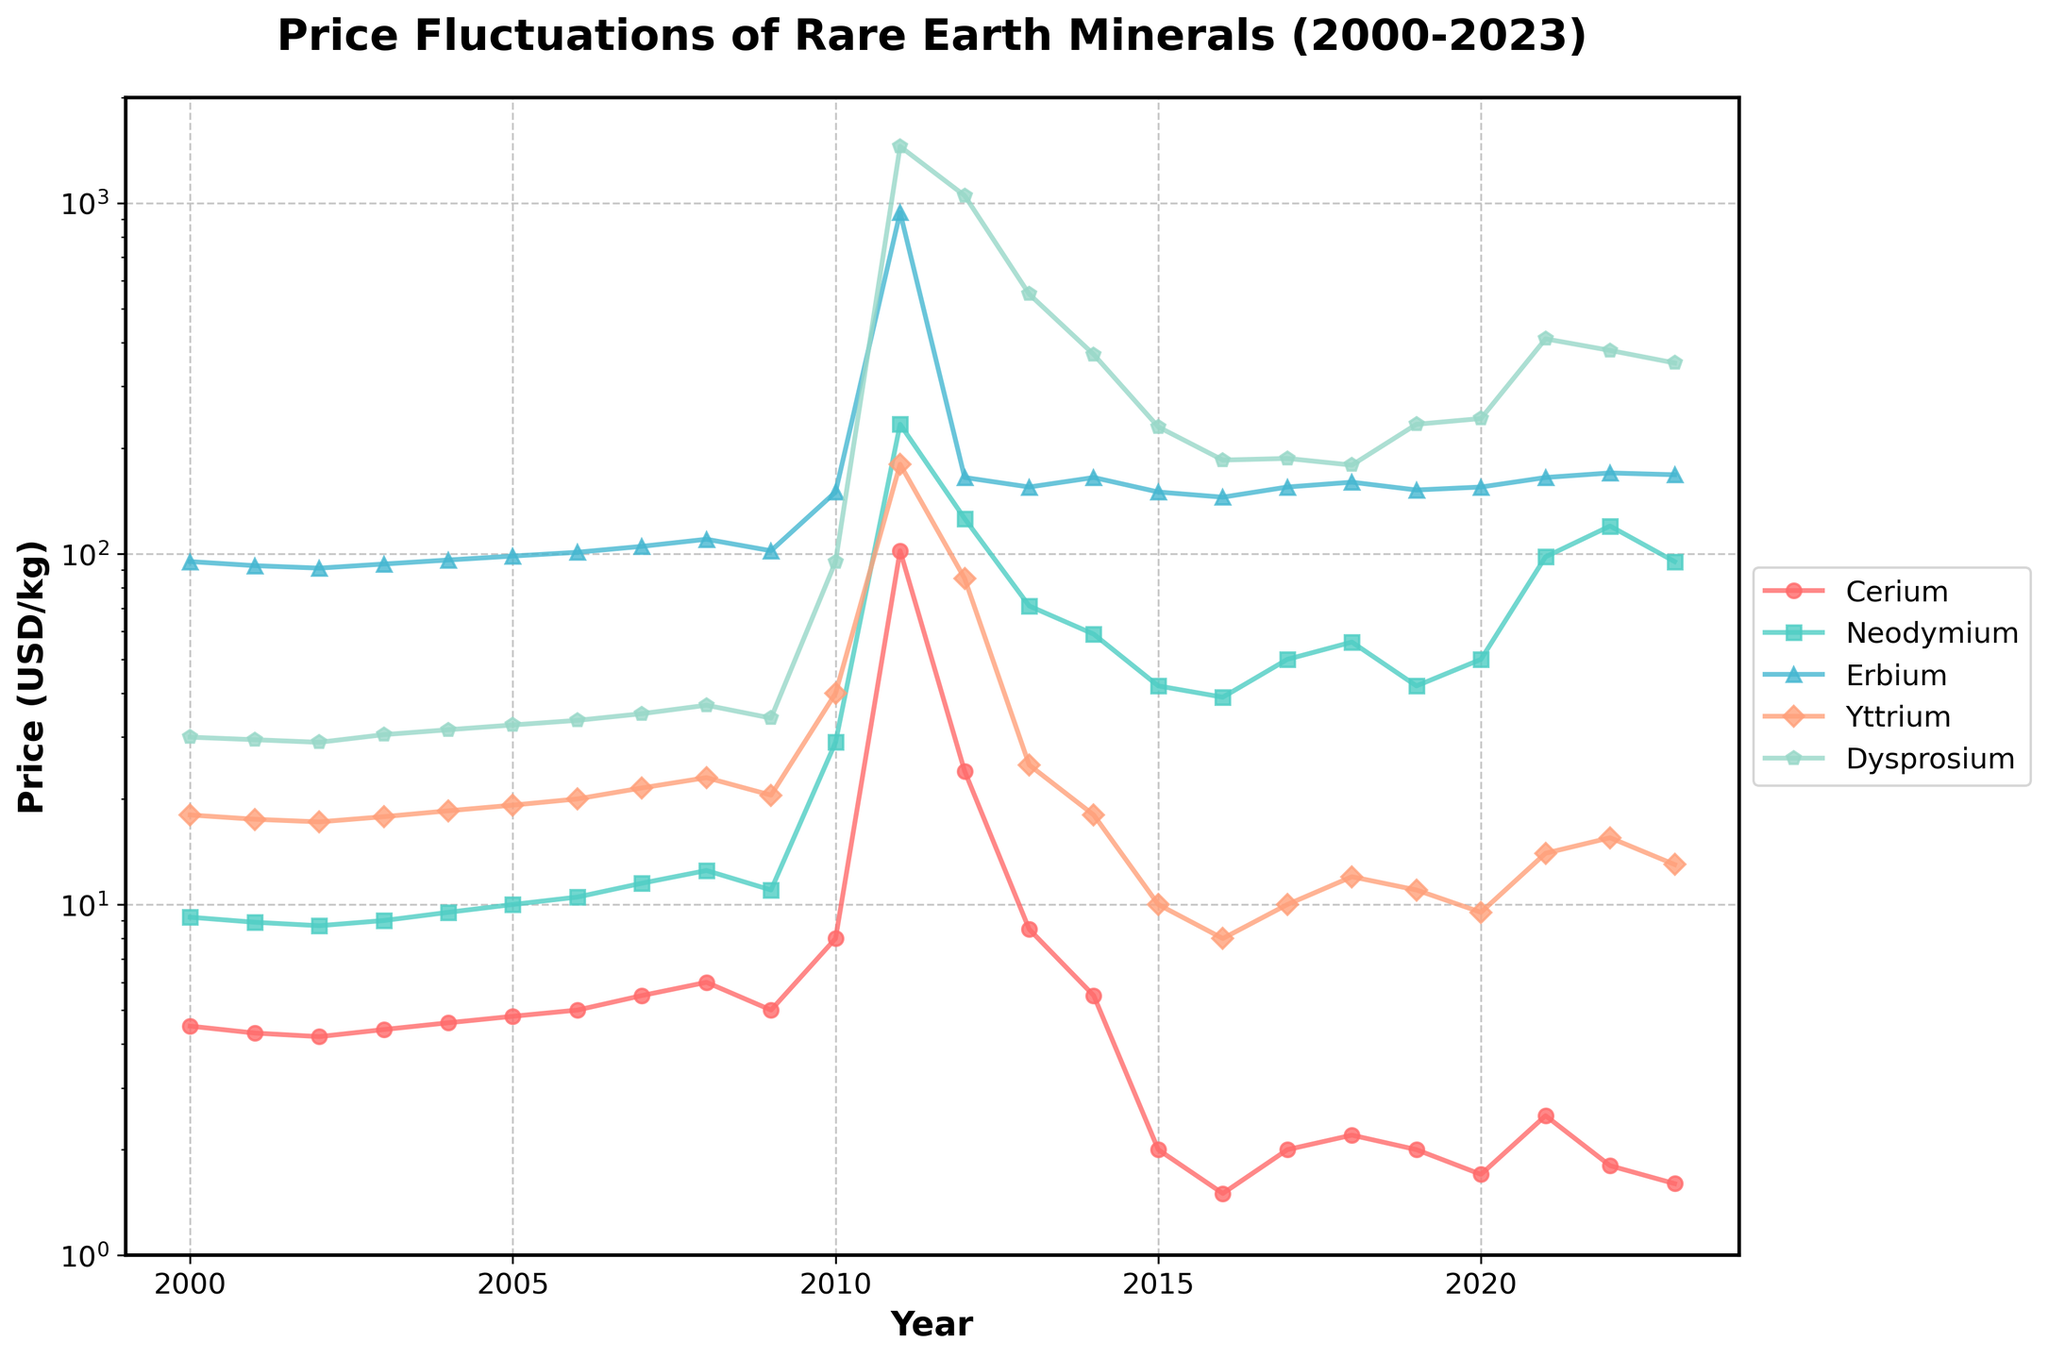What year did Cerium prices peak and what was the value? Peak is evident in the year 2011. The Cerium price hit its highest value of 102 USD/kg.
Answer: 2011, 102 Compare the prices of Neodymium in 2011 and 2023. How much higher was the price in 2011? Neodymium was priced at 234 USD/kg in 2011 and 95 USD/kg in 2023. The price was higher by 234 - 95 = 139 USD/kg in 2011.
Answer: 139 Which rare earth mineral showed the most significant price spike between 2010 and 2011? From 2010 to 2011, Dysprosium's price increased from 95 USD/kg to 1450 USD/kg, showing the most significant spike.
Answer: Dysprosium How does the price of Erbium in 2000 compare to its price in 2023? Erbium's price was 95 USD/kg in 2000 and 168 USD/kg in 2023, indicating an increase of 168 - 95 = 73 USD/kg.
Answer: 73 Between 2011 and 2023, which mineral experienced the most consistent decrease in price? Cerium experienced a consistent price decrease from 102 USD/kg in 2011 to 1.6 USD/kg in 2023.
Answer: Cerium On what dates did Yttrium have its lowest and highest recorded prices, and what were those values? Yttrium had its lowest price in 2016 at 8 USD/kg and its highest in 2011 at 180 USD/kg.
Answer: 2016, 8; 2011, 180 What is the price range (difference between the highest and lowest prices) for Dysprosium across the given years? The lowest price for Dysprosium was 29 USD/kg in 2002 and the highest was 1450 USD/kg in 2011, yielding a range of 1450 - 29 = 1421 USD/kg.
Answer: 1421 How is the price trend of Neodymium from 2008 to 2013 different from Cerium’s trend in the same period? Neodymium's price increased consistently from 12.5 to 71 USD/kg between 2008 and 2013. Cerium prices soared from 6 to 102 USD/kg between 2008 and 2011 but drastically dropped to 8.5 USD/kg in 2013.
Answer: Divergent trends What were the prices of Dysprosium and Yttrium in 2013? Which was higher? In 2013, Dysprosium was priced at 550 USD/kg and Yttrium at 25 USD/kg. Dysprosium had the higher price.
Answer: Dysprosium Considering the prices in 2020, which mineral was the least expensive and which was the most expensive? In 2020, the least expensive mineral was Cerium at 1.7 USD/kg, and the most expensive was Dysprosium at 243 USD/kg.
Answer: Cerium, Dysprosium 